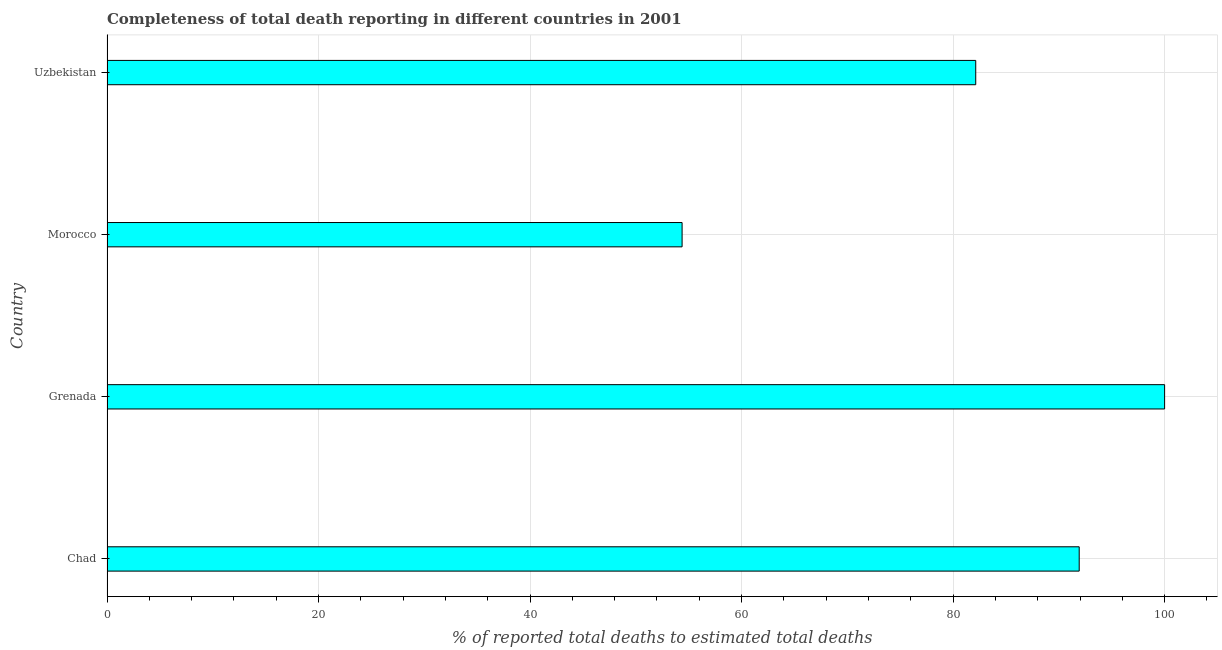Does the graph contain grids?
Give a very brief answer. Yes. What is the title of the graph?
Your answer should be compact. Completeness of total death reporting in different countries in 2001. What is the label or title of the X-axis?
Provide a short and direct response. % of reported total deaths to estimated total deaths. What is the completeness of total death reports in Uzbekistan?
Keep it short and to the point. 82.14. Across all countries, what is the minimum completeness of total death reports?
Your response must be concise. 54.38. In which country was the completeness of total death reports maximum?
Provide a short and direct response. Grenada. In which country was the completeness of total death reports minimum?
Give a very brief answer. Morocco. What is the sum of the completeness of total death reports?
Ensure brevity in your answer.  328.44. What is the difference between the completeness of total death reports in Grenada and Uzbekistan?
Provide a succinct answer. 17.86. What is the average completeness of total death reports per country?
Make the answer very short. 82.11. What is the median completeness of total death reports?
Offer a terse response. 87.03. In how many countries, is the completeness of total death reports greater than 76 %?
Ensure brevity in your answer.  3. What is the ratio of the completeness of total death reports in Morocco to that in Uzbekistan?
Make the answer very short. 0.66. Is the completeness of total death reports in Grenada less than that in Uzbekistan?
Make the answer very short. No. Is the difference between the completeness of total death reports in Morocco and Uzbekistan greater than the difference between any two countries?
Provide a short and direct response. No. What is the difference between the highest and the second highest completeness of total death reports?
Provide a succinct answer. 8.07. What is the difference between the highest and the lowest completeness of total death reports?
Keep it short and to the point. 45.62. Are all the bars in the graph horizontal?
Offer a terse response. Yes. What is the difference between two consecutive major ticks on the X-axis?
Your answer should be compact. 20. What is the % of reported total deaths to estimated total deaths in Chad?
Keep it short and to the point. 91.92. What is the % of reported total deaths to estimated total deaths in Morocco?
Your answer should be compact. 54.38. What is the % of reported total deaths to estimated total deaths in Uzbekistan?
Provide a short and direct response. 82.14. What is the difference between the % of reported total deaths to estimated total deaths in Chad and Grenada?
Your answer should be compact. -8.08. What is the difference between the % of reported total deaths to estimated total deaths in Chad and Morocco?
Keep it short and to the point. 37.55. What is the difference between the % of reported total deaths to estimated total deaths in Chad and Uzbekistan?
Keep it short and to the point. 9.78. What is the difference between the % of reported total deaths to estimated total deaths in Grenada and Morocco?
Your answer should be very brief. 45.62. What is the difference between the % of reported total deaths to estimated total deaths in Grenada and Uzbekistan?
Offer a very short reply. 17.86. What is the difference between the % of reported total deaths to estimated total deaths in Morocco and Uzbekistan?
Offer a terse response. -27.76. What is the ratio of the % of reported total deaths to estimated total deaths in Chad to that in Grenada?
Your answer should be compact. 0.92. What is the ratio of the % of reported total deaths to estimated total deaths in Chad to that in Morocco?
Provide a short and direct response. 1.69. What is the ratio of the % of reported total deaths to estimated total deaths in Chad to that in Uzbekistan?
Offer a terse response. 1.12. What is the ratio of the % of reported total deaths to estimated total deaths in Grenada to that in Morocco?
Keep it short and to the point. 1.84. What is the ratio of the % of reported total deaths to estimated total deaths in Grenada to that in Uzbekistan?
Make the answer very short. 1.22. What is the ratio of the % of reported total deaths to estimated total deaths in Morocco to that in Uzbekistan?
Your response must be concise. 0.66. 